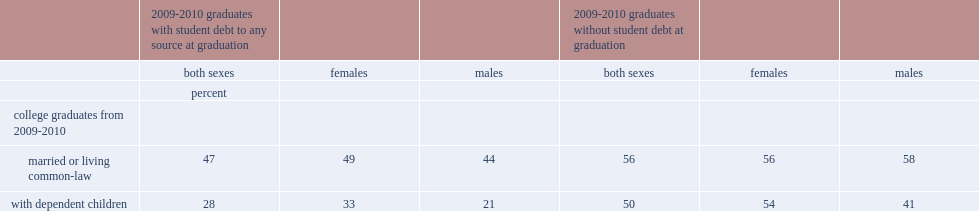What was the percentage of women with student debt at graduation that were married? 49.0. What was the percentage of women without student debt at graduation that were married? 56.0. Which kind of women were more likely to have been married, female students with debt or without debt? 2009-2010 graduates without student debt at graduation. What was the percentage of female college graduates with student debt had dependent children? 33.0. What was the percentage of female college graduates with no student debt had dependent children? 54.0. Which kind of women were less likely to have dependent children, female students with debt or without debt? 2009-2010 graduates with student debt to any source at graduation. Could you parse the entire table as a dict? {'header': ['', '2009-2010 graduates with student debt to any source at graduation', '', '', '2009-2010 graduates without student debt at graduation', '', ''], 'rows': [['', 'both sexes', 'females', 'males', 'both sexes', 'females', 'males'], ['', 'percent', '', '', '', '', ''], ['college graduates from 2009-2010', '', '', '', '', '', ''], ['married or living common-law', '47', '49', '44', '56', '56', '58'], ['with dependent children', '28', '33', '21', '50', '54', '41']]} 